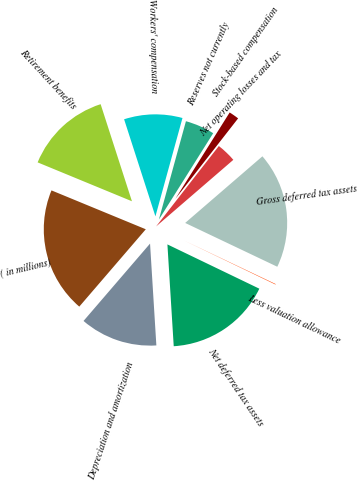Convert chart to OTSL. <chart><loc_0><loc_0><loc_500><loc_500><pie_chart><fcel>( in millions)<fcel>Retirement benefits<fcel>Workers' compensation<fcel>Reserves not currently<fcel>Stock-based compensation<fcel>Net operating losses and tax<fcel>Gross deferred tax assets<fcel>Less valuation allowance<fcel>Net deferred tax assets<fcel>Depreciation and amortization<nl><fcel>19.92%<fcel>13.81%<fcel>9.24%<fcel>4.66%<fcel>1.61%<fcel>3.13%<fcel>18.39%<fcel>0.08%<fcel>16.87%<fcel>12.29%<nl></chart> 